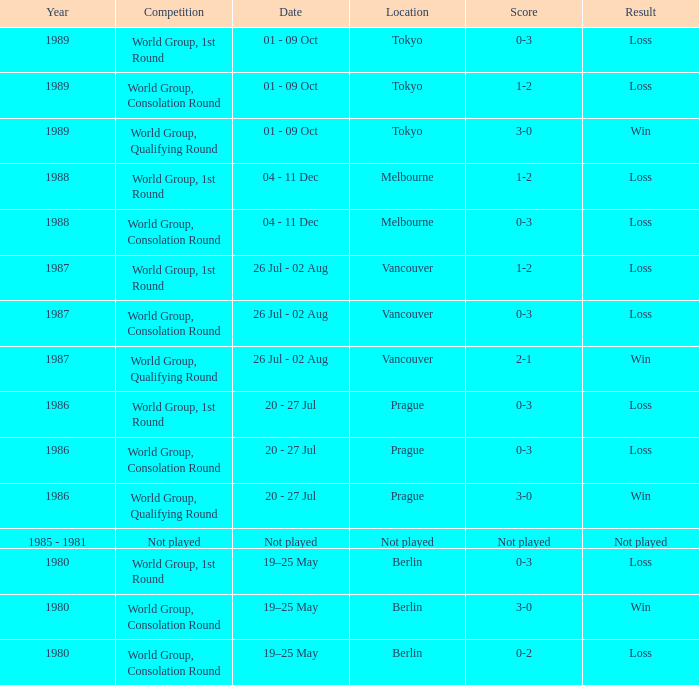What is the date for the game in prague for the world group, consolation round competition? 20 - 27 Jul. Parse the full table. {'header': ['Year', 'Competition', 'Date', 'Location', 'Score', 'Result'], 'rows': [['1989', 'World Group, 1st Round', '01 - 09 Oct', 'Tokyo', '0-3', 'Loss'], ['1989', 'World Group, Consolation Round', '01 - 09 Oct', 'Tokyo', '1-2', 'Loss'], ['1989', 'World Group, Qualifying Round', '01 - 09 Oct', 'Tokyo', '3-0', 'Win'], ['1988', 'World Group, 1st Round', '04 - 11 Dec', 'Melbourne', '1-2', 'Loss'], ['1988', 'World Group, Consolation Round', '04 - 11 Dec', 'Melbourne', '0-3', 'Loss'], ['1987', 'World Group, 1st Round', '26 Jul - 02 Aug', 'Vancouver', '1-2', 'Loss'], ['1987', 'World Group, Consolation Round', '26 Jul - 02 Aug', 'Vancouver', '0-3', 'Loss'], ['1987', 'World Group, Qualifying Round', '26 Jul - 02 Aug', 'Vancouver', '2-1', 'Win'], ['1986', 'World Group, 1st Round', '20 - 27 Jul', 'Prague', '0-3', 'Loss'], ['1986', 'World Group, Consolation Round', '20 - 27 Jul', 'Prague', '0-3', 'Loss'], ['1986', 'World Group, Qualifying Round', '20 - 27 Jul', 'Prague', '3-0', 'Win'], ['1985 - 1981', 'Not played', 'Not played', 'Not played', 'Not played', 'Not played'], ['1980', 'World Group, 1st Round', '19–25 May', 'Berlin', '0-3', 'Loss'], ['1980', 'World Group, Consolation Round', '19–25 May', 'Berlin', '3-0', 'Win'], ['1980', 'World Group, Consolation Round', '19–25 May', 'Berlin', '0-2', 'Loss']]} 